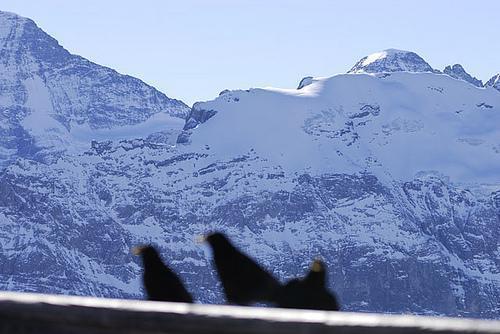How many birds are in the picture?
Give a very brief answer. 3. 